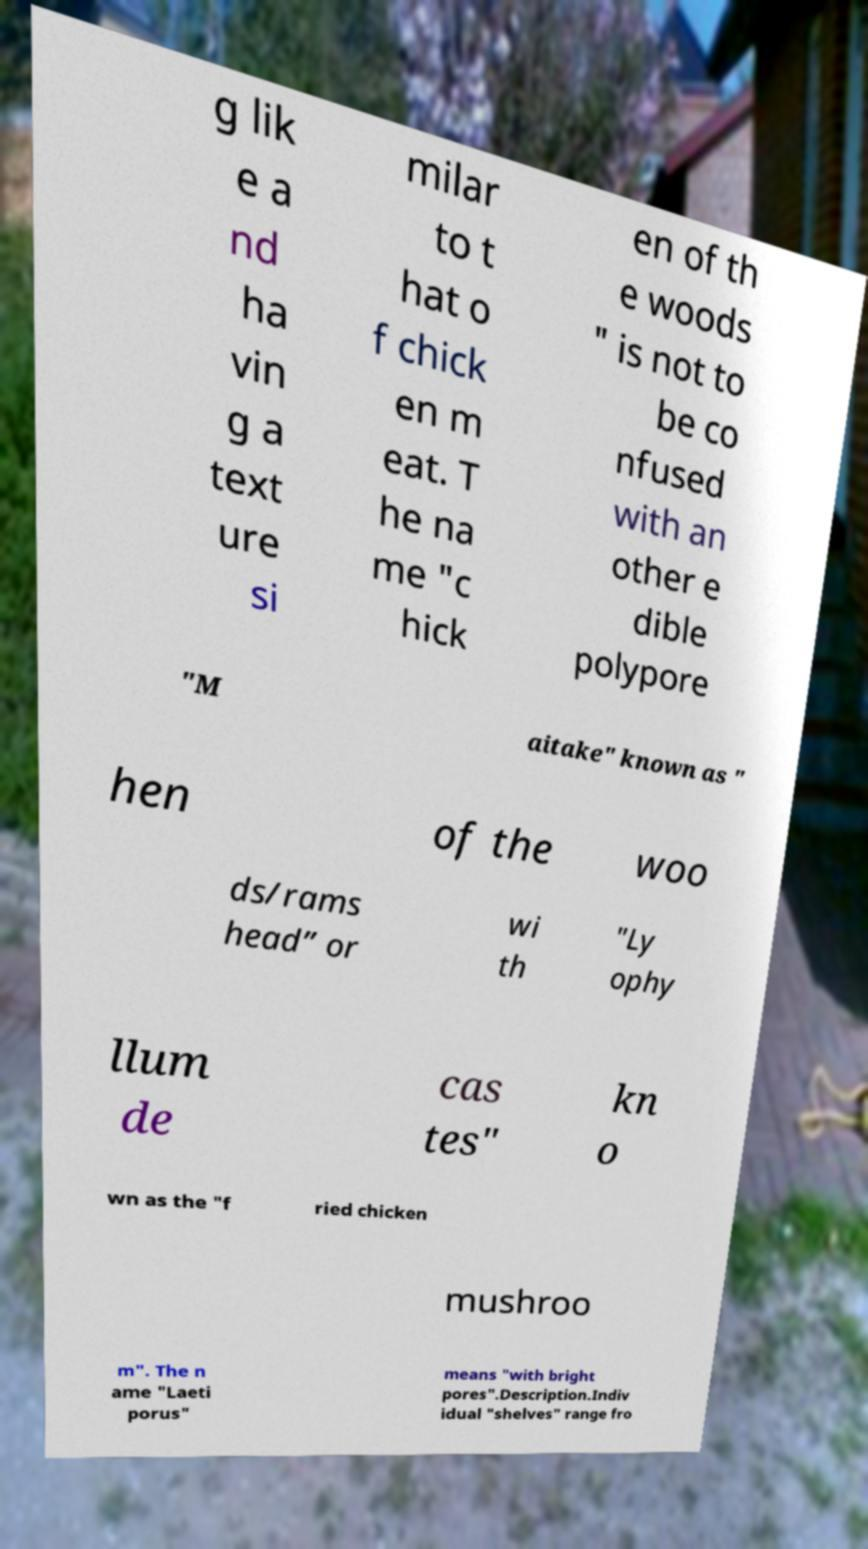For documentation purposes, I need the text within this image transcribed. Could you provide that? g lik e a nd ha vin g a text ure si milar to t hat o f chick en m eat. T he na me "c hick en of th e woods " is not to be co nfused with an other e dible polypore "M aitake" known as " hen of the woo ds/rams head” or wi th "Ly ophy llum de cas tes" kn o wn as the "f ried chicken mushroo m". The n ame "Laeti porus" means "with bright pores".Description.Indiv idual "shelves" range fro 